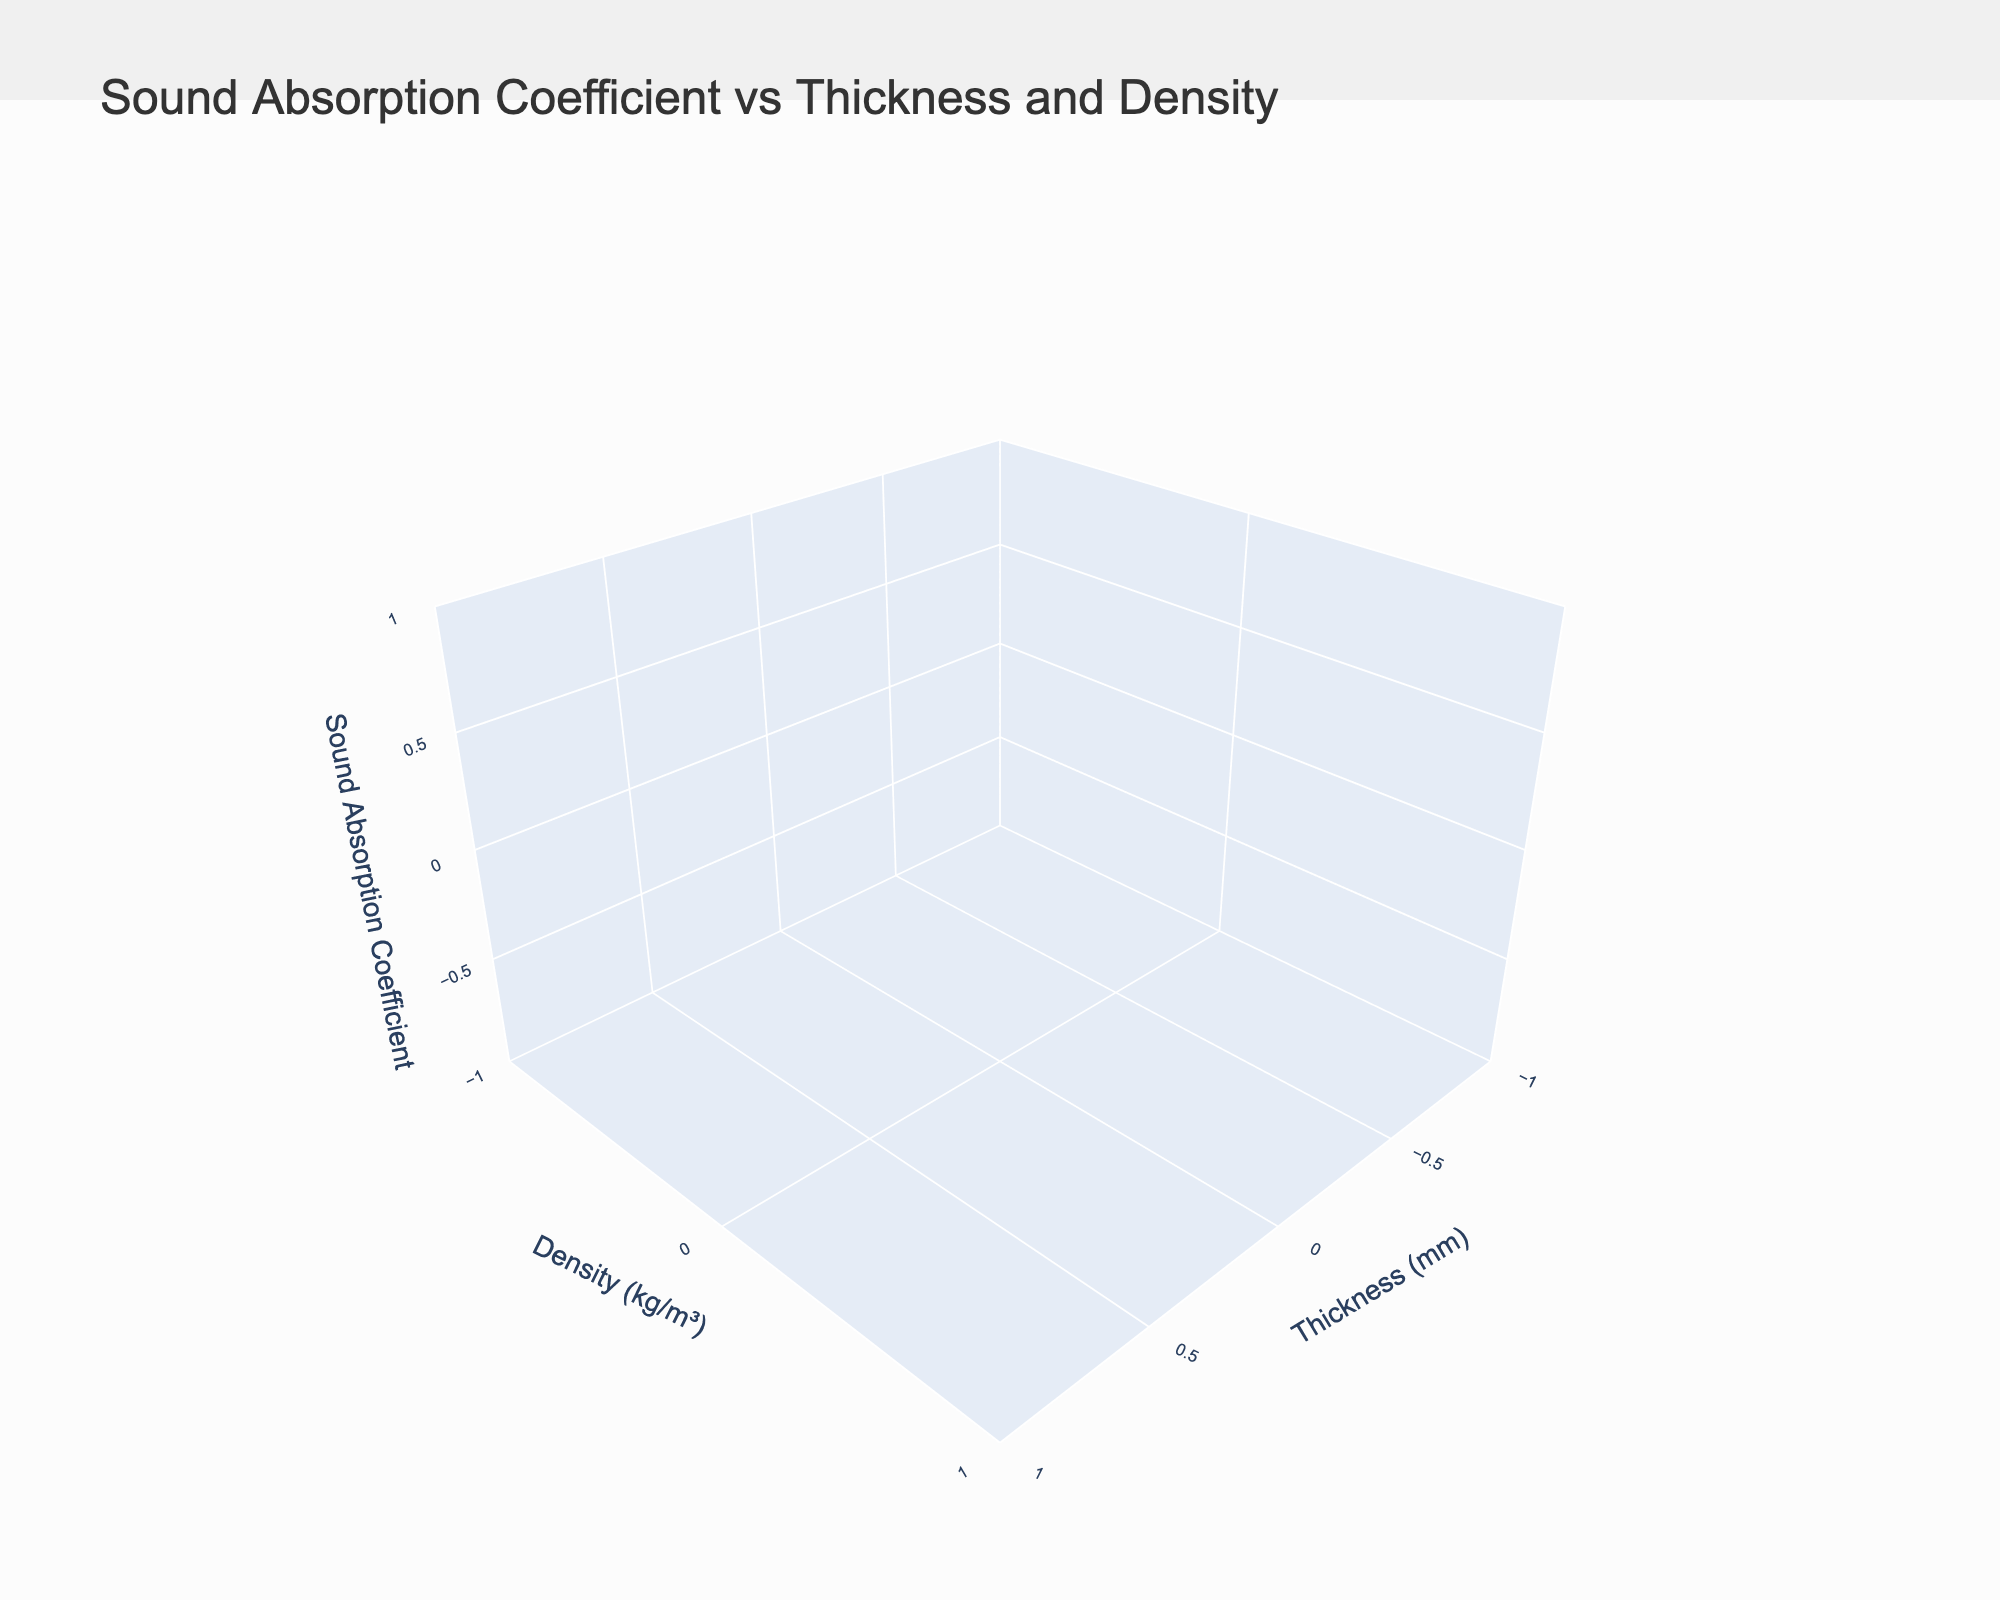What's the title of the plot? The title is usually displayed at the top center of the plot. In this plot, the title is specified to be "Sound Absorption Coefficient vs Thickness and Density".
Answer: Sound Absorption Coefficient vs Thickness and Density What does the Z-axis represent on the plot? The Z-axis title can be found in the specified plot layout. The text associated with the Z-axis in this plot is "Sound Absorption Coefficient".
Answer: Sound Absorption Coefficient How many distinct materials are represented in the plot? The plot has a legend on the right side showing different materials. The code outlines three unique materials: 'Glass Fiber', 'Polyurethane Foam', 'Recycled Rubber'.
Answer: Three Which material has the highest sound absorption coefficient? To determine the highest sound absorption coefficient, look at the Z-axis values for each material and see which one reaches the maximum point. The code uses different surfaces for each material, aiding the identification.
Answer: Polyurethane Foam Which material shows the most change in sound absorption coefficient as thickness increases? Examine each material's surface from the plot and observe the gradient as thickness varies (X-axis). The steepest gradient indicates the most significant change. Based on the data, 'Glass Fiber' shows a significant change.
Answer: Glass Fiber At a density of 500 kg/m³, which material has the lowest sound absorption coefficient at 30 mm thickness? Locate the density of 500 kg/m³ on the Y-axis and check the sound absorption coefficient values for the three materials when thickness is at 30 mm. Compare these values to identify the lowest.
Answer: Recycled Rubber Comparing Glass Fiber and Polyurethane Foam, which has a higher sound absorption coefficient at 20 mm and a density of 50 kg/m³? Find the specific point where thickness is 20 mm and density is 50 kg/m³ and compare the Z-axis values for both materials at this point.
Answer: Glass Fiber Which material is most effective at sound absorption with the least density and thickness? Look for the data points with the lowest density and thickness values on the X and Y axes, then check the Z-axis values to find the highest sound absorption coefficient. 'Glass Fiber' at 10 mm thickness and 50 kg/m³ usually shows higher absorption in general trends.
Answer: Glass Fiber What is the sound absorption coefficient for Recycled Rubber at maximum thickness and density? Search for the Recycled Rubber surface and locate the point with the maximum values on both X-axis (thickness) and Y-axis (density), then read the Z-axis value.
Answer: 0.75 